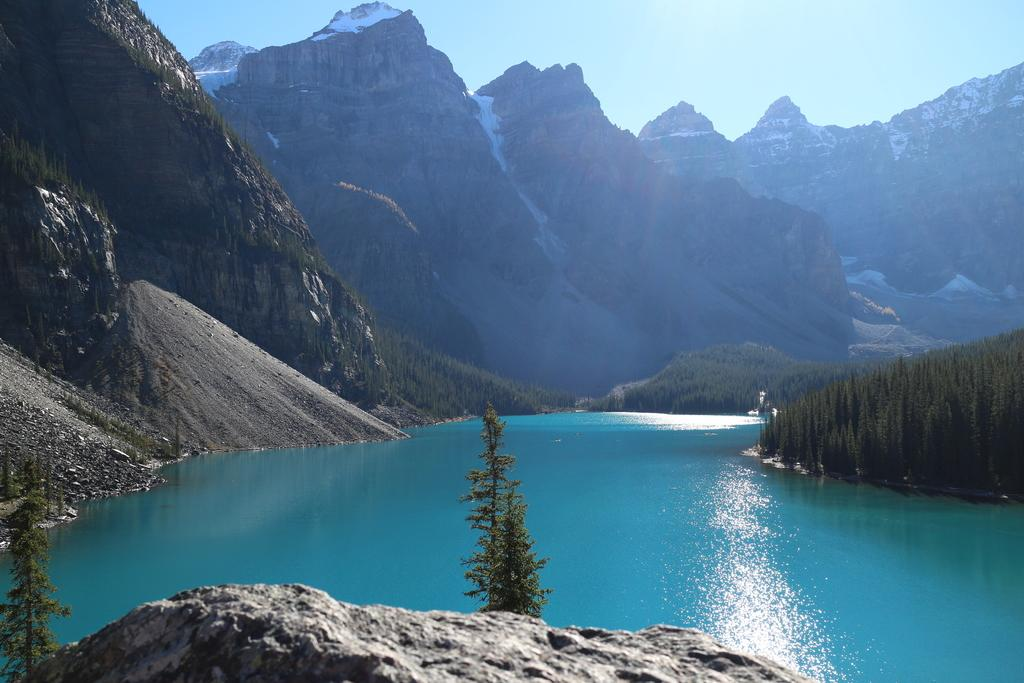What is the main feature in the center of the image? There is water in the center of the image. What type of natural landforms can be seen in the image? There are mountains in the image. What type of vegetation is present in the image? There are trees in the image. What type of comb can be seen in the aftermath of the image? There is no comb or aftermath present in the image; it features water, mountains, and trees. 